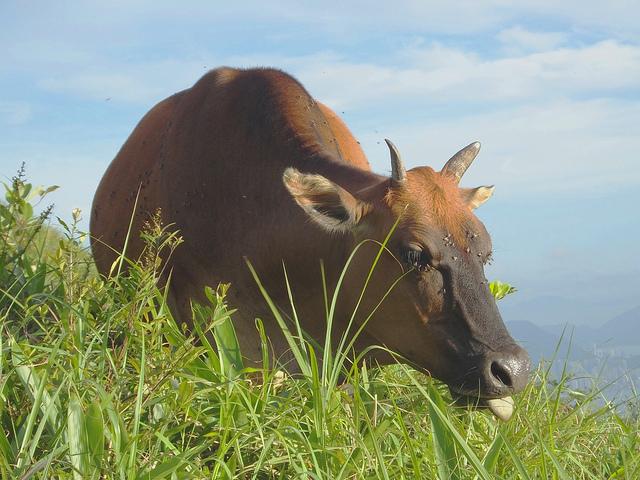How many brown cows are there?
Keep it brief. 1. What are the cows doing?
Quick response, please. Eating. Is it sunny?
Answer briefly. Yes. IS this animal in the grass?
Quick response, please. Yes. What is on this animals head?
Be succinct. Horns. What is around the cow's neck?
Quick response, please. Nothing. 